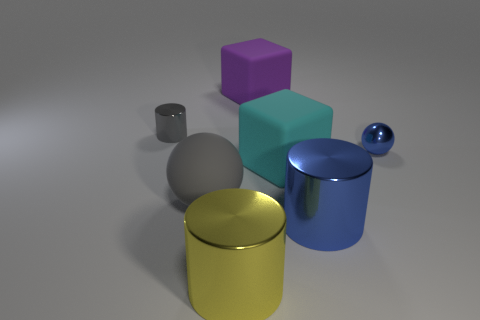Add 3 small gray rubber cylinders. How many objects exist? 10 Subtract all cylinders. How many objects are left? 4 Add 1 big purple things. How many big purple things are left? 2 Add 3 shiny blocks. How many shiny blocks exist? 3 Subtract 1 purple blocks. How many objects are left? 6 Subtract all big cyan blocks. Subtract all big blocks. How many objects are left? 4 